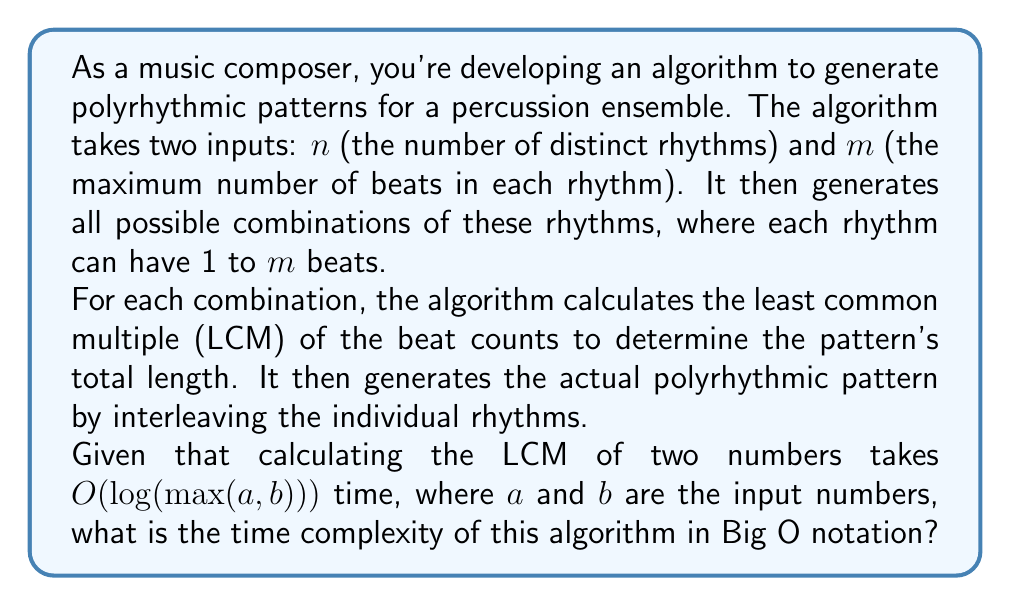Give your solution to this math problem. Let's break down the algorithm and analyze its runtime step by step:

1. Generating all possible combinations of rhythms:
   - There are $m$ choices for each of the $n$ rhythms.
   - Total number of combinations: $m^n$

2. For each combination:
   a. Calculate the LCM of the beat counts:
      - We need to calculate the LCM of $n$ numbers.
      - LCM of two numbers takes $O(\log m)$ time (since $m$ is the maximum beat count).
      - To calculate LCM of $n$ numbers, we need $n-1$ pairwise LCM operations.
      - Time for LCM calculation: $O(n \log m)$

   b. Generate the actual polyrhythmic pattern:
      - The length of the pattern is at most the product of all beat counts, which is $O(m^n)$.
      - Generating the pattern takes time proportional to its length.
      - Time for pattern generation: $O(m^n)$

3. Total time for each combination:
   $O(n \log m + m^n)$, which simplifies to $O(m^n)$ since $m^n$ dominates $n \log m$ for large $m$ and $n$.

4. Overall time complexity:
   - Number of combinations: $m^n$
   - Time per combination: $O(m^n)$
   - Total time: $O(m^n \cdot m^n) = O(m^{2n})$

Therefore, the time complexity of the algorithm is $O(m^{2n})$.
Answer: $O(m^{2n})$ 